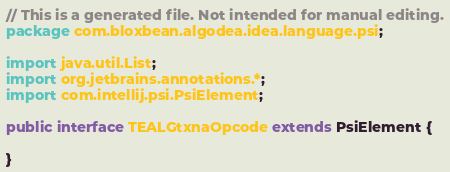<code> <loc_0><loc_0><loc_500><loc_500><_Java_>// This is a generated file. Not intended for manual editing.
package com.bloxbean.algodea.idea.language.psi;

import java.util.List;
import org.jetbrains.annotations.*;
import com.intellij.psi.PsiElement;

public interface TEALGtxnaOpcode extends PsiElement {

}
</code> 